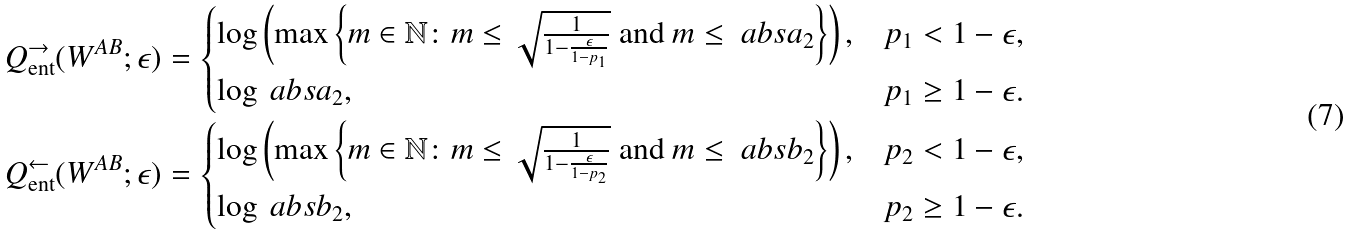<formula> <loc_0><loc_0><loc_500><loc_500>Q _ { \text {ent} } ^ { \rightarrow } ( W ^ { A B } ; \epsilon ) = \begin{cases} \log \left ( \max \left \{ m \in \mathbb { N } \colon m \leq \sqrt { \frac { 1 } { 1 - \frac { \epsilon } { 1 - p _ { 1 } } } } \text { and } m \leq \ a b s { a _ { 2 } } \right \} \right ) , & p _ { 1 } < 1 - \epsilon , \\ \log \ a b s { a _ { 2 } } , & p _ { 1 } \geq 1 - \epsilon . \end{cases} \\ Q _ { \text {ent} } ^ { \leftarrow } ( W ^ { A B } ; \epsilon ) = \begin{cases} \log \left ( \max \left \{ m \in \mathbb { N } \colon m \leq \sqrt { \frac { 1 } { 1 - \frac { \epsilon } { 1 - p _ { 2 } } } } \text { and } m \leq \ a b s { b _ { 2 } } \right \} \right ) , & p _ { 2 } < 1 - \epsilon , \\ \log \ a b s { b _ { 2 } } , & p _ { 2 } \geq 1 - \epsilon . \end{cases}</formula> 